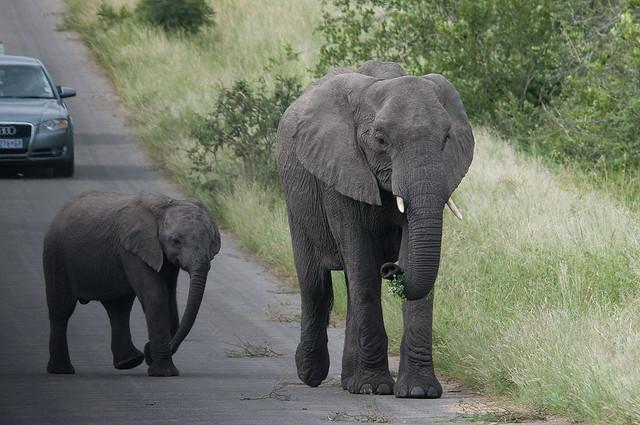What movie character fits in with these animals?

Choices:
A) benji
B) mr ed
C) garfield
D) dumbo dumbo 